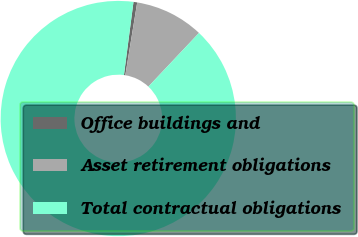<chart> <loc_0><loc_0><loc_500><loc_500><pie_chart><fcel>Office buildings and<fcel>Asset retirement obligations<fcel>Total contractual obligations<nl><fcel>0.51%<fcel>9.46%<fcel>90.03%<nl></chart> 